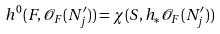<formula> <loc_0><loc_0><loc_500><loc_500>h ^ { 0 } ( F , \mathcal { O } _ { F } ( N ^ { \prime } _ { j } ) ) = \chi ( S , h _ { * } \mathcal { O } _ { F } ( N ^ { \prime } _ { j } ) )</formula> 